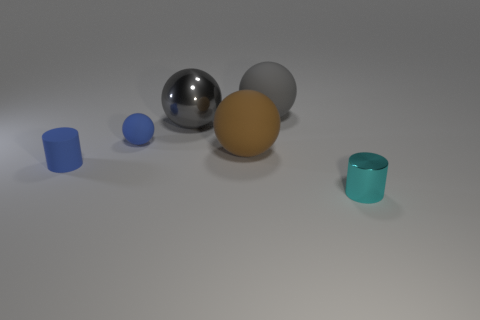Subtract all brown blocks. How many gray balls are left? 2 Subtract 2 balls. How many balls are left? 2 Subtract all blue spheres. How many spheres are left? 3 Subtract all blue matte spheres. How many spheres are left? 3 Subtract all purple balls. Subtract all cyan blocks. How many balls are left? 4 Add 3 rubber cylinders. How many objects exist? 9 Subtract all cylinders. How many objects are left? 4 Subtract all metallic things. Subtract all big brown matte cylinders. How many objects are left? 4 Add 6 tiny cyan cylinders. How many tiny cyan cylinders are left? 7 Add 2 matte things. How many matte things exist? 6 